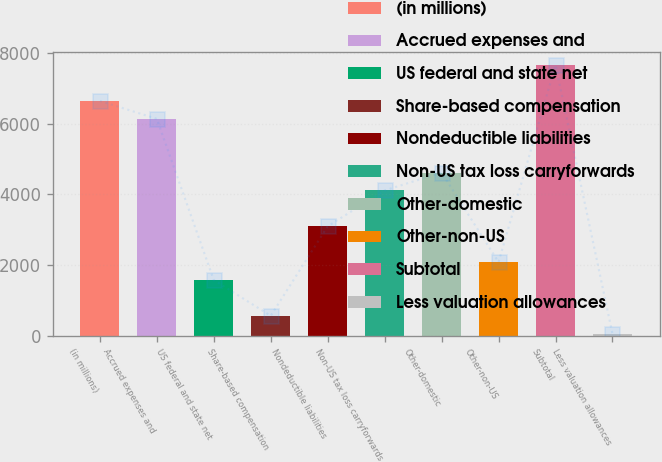Convert chart. <chart><loc_0><loc_0><loc_500><loc_500><bar_chart><fcel>(in millions)<fcel>Accrued expenses and<fcel>US federal and state net<fcel>Share-based compensation<fcel>Nondeductible liabilities<fcel>Non-US tax loss carryforwards<fcel>Other-domestic<fcel>Other-non-US<fcel>Subtotal<fcel>Less valuation allowances<nl><fcel>6639.5<fcel>6133<fcel>1574.5<fcel>561.5<fcel>3094<fcel>4107<fcel>4613.5<fcel>2081<fcel>7652.5<fcel>55<nl></chart> 